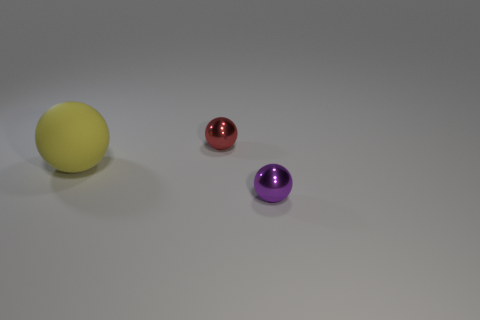Add 3 purple balls. How many objects exist? 6 Subtract all metal spheres. How many spheres are left? 1 Subtract 2 spheres. How many spheres are left? 1 Add 3 large rubber spheres. How many large rubber spheres are left? 4 Add 3 red cubes. How many red cubes exist? 3 Subtract 0 cyan spheres. How many objects are left? 3 Subtract all gray balls. Subtract all yellow cylinders. How many balls are left? 3 Subtract all tiny gray spheres. Subtract all red metal spheres. How many objects are left? 2 